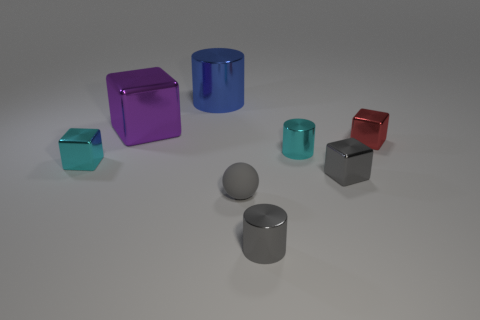What number of other things are there of the same color as the small matte thing?
Offer a very short reply. 2. How many cubes are the same color as the small rubber object?
Give a very brief answer. 1. Are there fewer cyan cylinders behind the blue thing than small cyan metal objects?
Keep it short and to the point. Yes. There is a large thing that is the same material as the blue cylinder; what is its shape?
Your answer should be very brief. Cube. How many shiny things are gray things or big cubes?
Provide a succinct answer. 3. Is the number of small red things that are behind the big purple metallic thing the same as the number of tiny cylinders?
Ensure brevity in your answer.  No. Does the small object on the left side of the gray matte thing have the same color as the big metal cylinder?
Make the answer very short. No. The thing that is both to the left of the matte object and in front of the large metal cube is made of what material?
Ensure brevity in your answer.  Metal. Are there any gray cubes that are behind the metal block that is behind the small red metal thing?
Offer a very short reply. No. Does the red block have the same material as the cyan cube?
Ensure brevity in your answer.  Yes. 